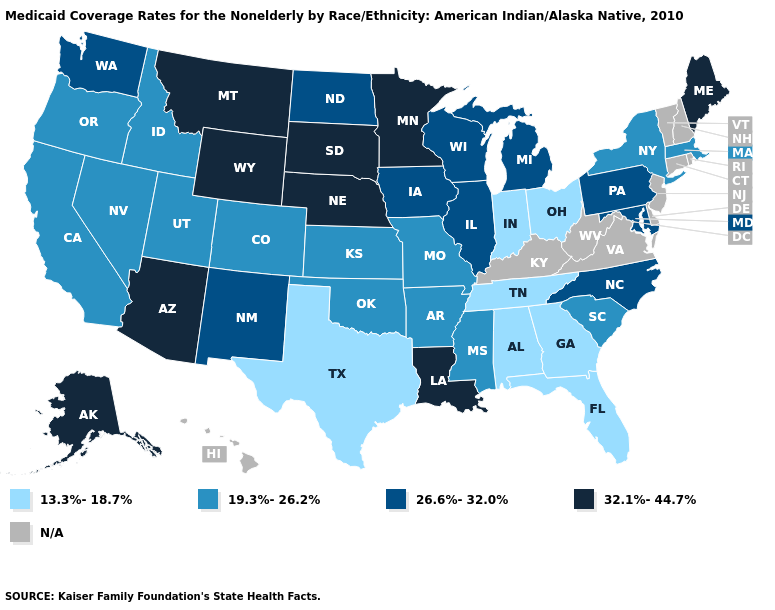Name the states that have a value in the range 26.6%-32.0%?
Write a very short answer. Illinois, Iowa, Maryland, Michigan, New Mexico, North Carolina, North Dakota, Pennsylvania, Washington, Wisconsin. How many symbols are there in the legend?
Give a very brief answer. 5. Does Wyoming have the highest value in the USA?
Keep it brief. Yes. What is the value of Minnesota?
Answer briefly. 32.1%-44.7%. What is the highest value in the USA?
Concise answer only. 32.1%-44.7%. What is the value of Alabama?
Answer briefly. 13.3%-18.7%. What is the value of Missouri?
Quick response, please. 19.3%-26.2%. Which states have the lowest value in the USA?
Short answer required. Alabama, Florida, Georgia, Indiana, Ohio, Tennessee, Texas. How many symbols are there in the legend?
Short answer required. 5. How many symbols are there in the legend?
Be succinct. 5. Does Ohio have the highest value in the MidWest?
Give a very brief answer. No. Among the states that border Louisiana , does Arkansas have the highest value?
Keep it brief. Yes. How many symbols are there in the legend?
Give a very brief answer. 5. Name the states that have a value in the range 32.1%-44.7%?
Concise answer only. Alaska, Arizona, Louisiana, Maine, Minnesota, Montana, Nebraska, South Dakota, Wyoming. 